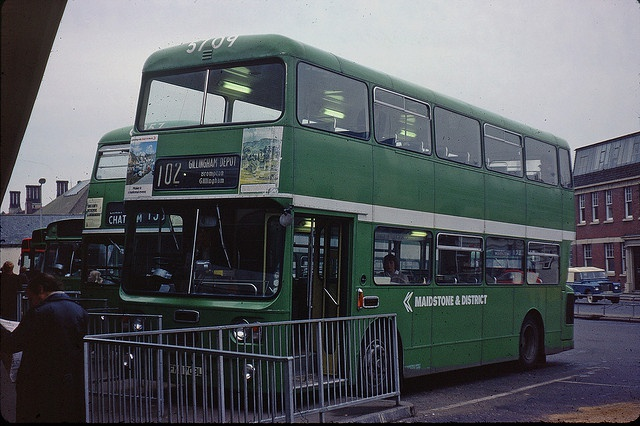Describe the objects in this image and their specific colors. I can see bus in black, gray, teal, and darkgreen tones, people in black, navy, gray, and maroon tones, bus in black, darkgray, gray, and darkgreen tones, bus in black, gray, and purple tones, and car in black, gray, navy, and darkgray tones in this image. 